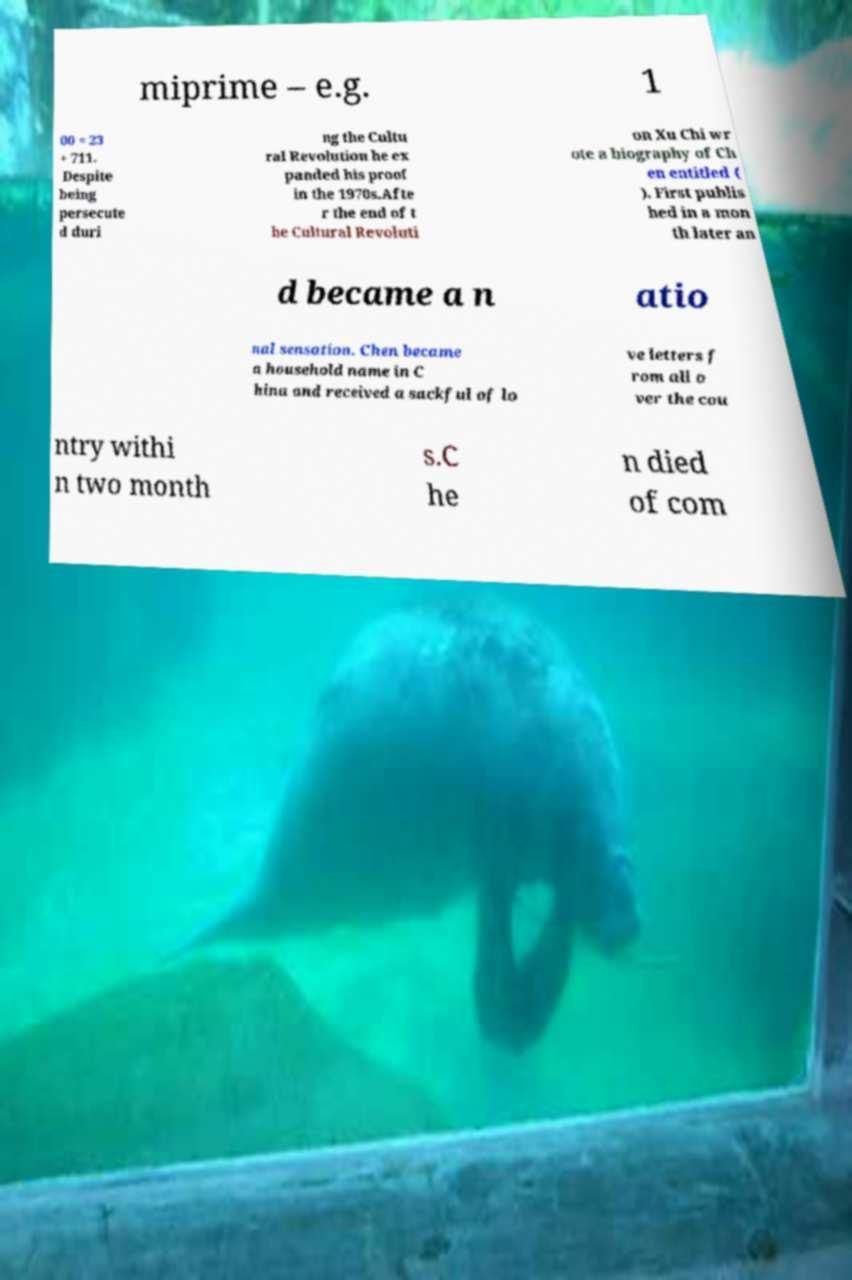Could you assist in decoding the text presented in this image and type it out clearly? miprime – e.g. 1 00 = 23 + 711. Despite being persecute d duri ng the Cultu ral Revolution he ex panded his proof in the 1970s.Afte r the end of t he Cultural Revoluti on Xu Chi wr ote a biography of Ch en entitled ( ). First publis hed in a mon th later an d became a n atio nal sensation. Chen became a household name in C hina and received a sackful of lo ve letters f rom all o ver the cou ntry withi n two month s.C he n died of com 